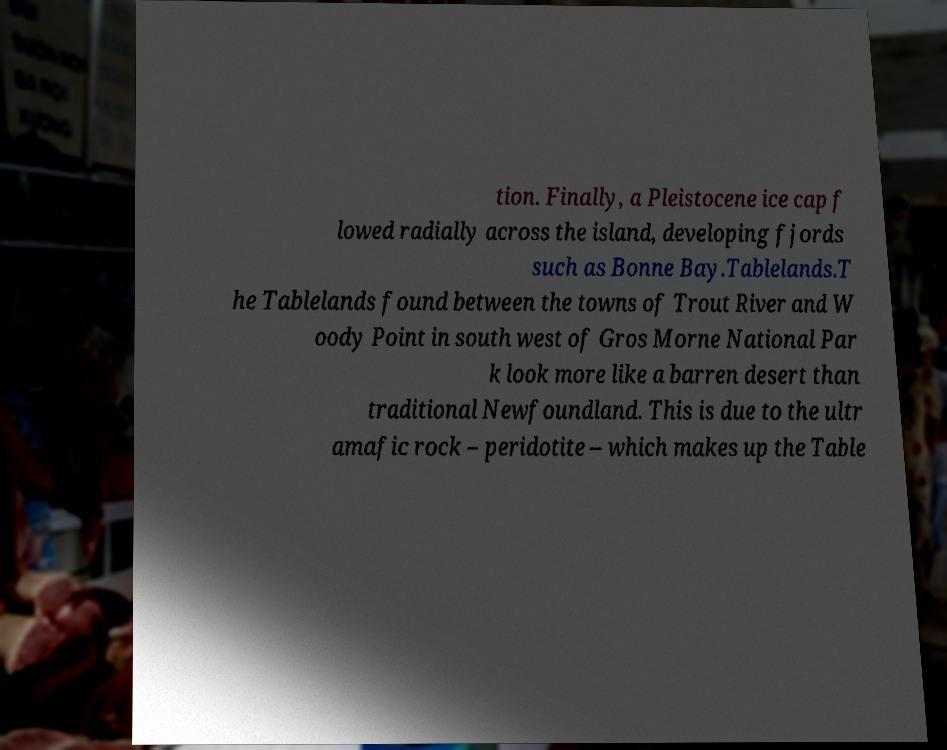Could you extract and type out the text from this image? tion. Finally, a Pleistocene ice cap f lowed radially across the island, developing fjords such as Bonne Bay.Tablelands.T he Tablelands found between the towns of Trout River and W oody Point in south west of Gros Morne National Par k look more like a barren desert than traditional Newfoundland. This is due to the ultr amafic rock – peridotite – which makes up the Table 